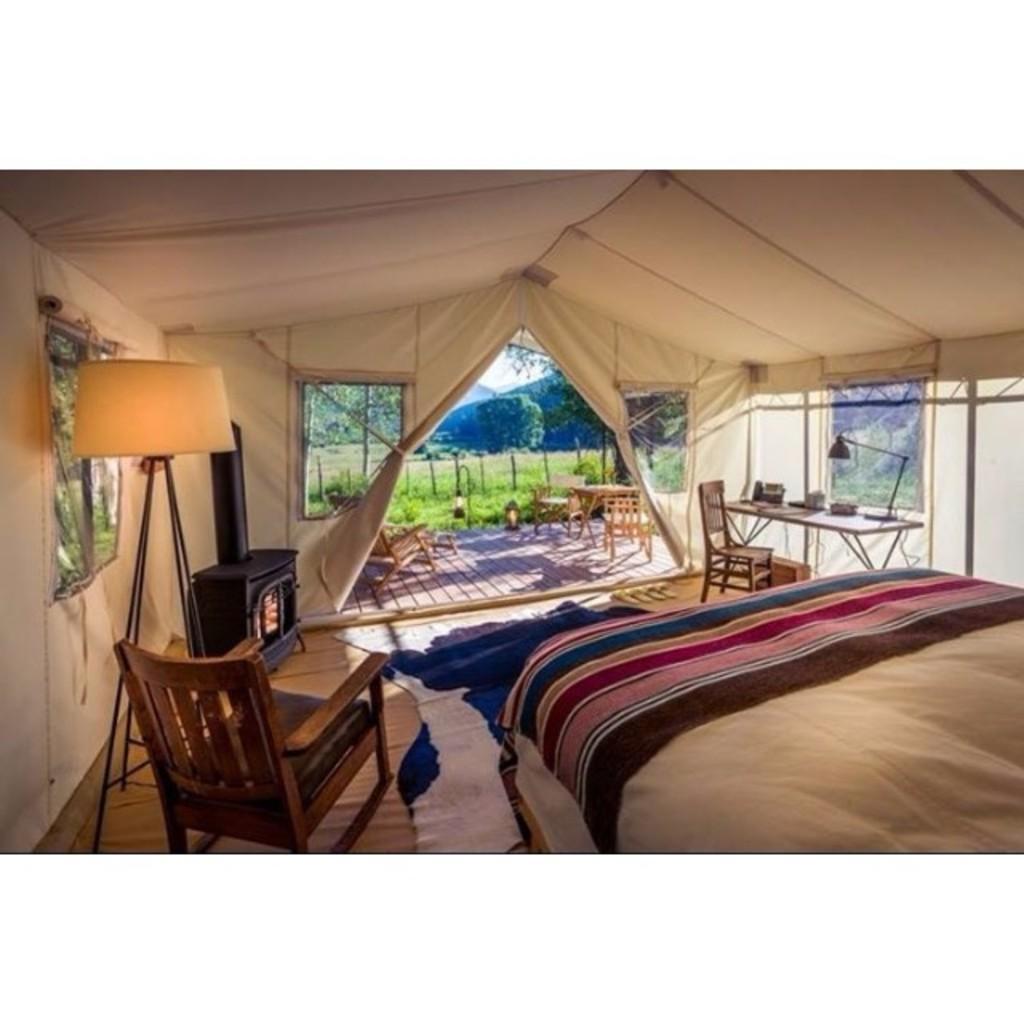In one or two sentences, can you explain what this image depicts? This image is taken in the camp. In this image there is a lamp, chair, table, bed, on the other side there is a table with some stuff on it and there is a chair. In the background there are chairs, tables, grass, trees, mountains and the sky. 